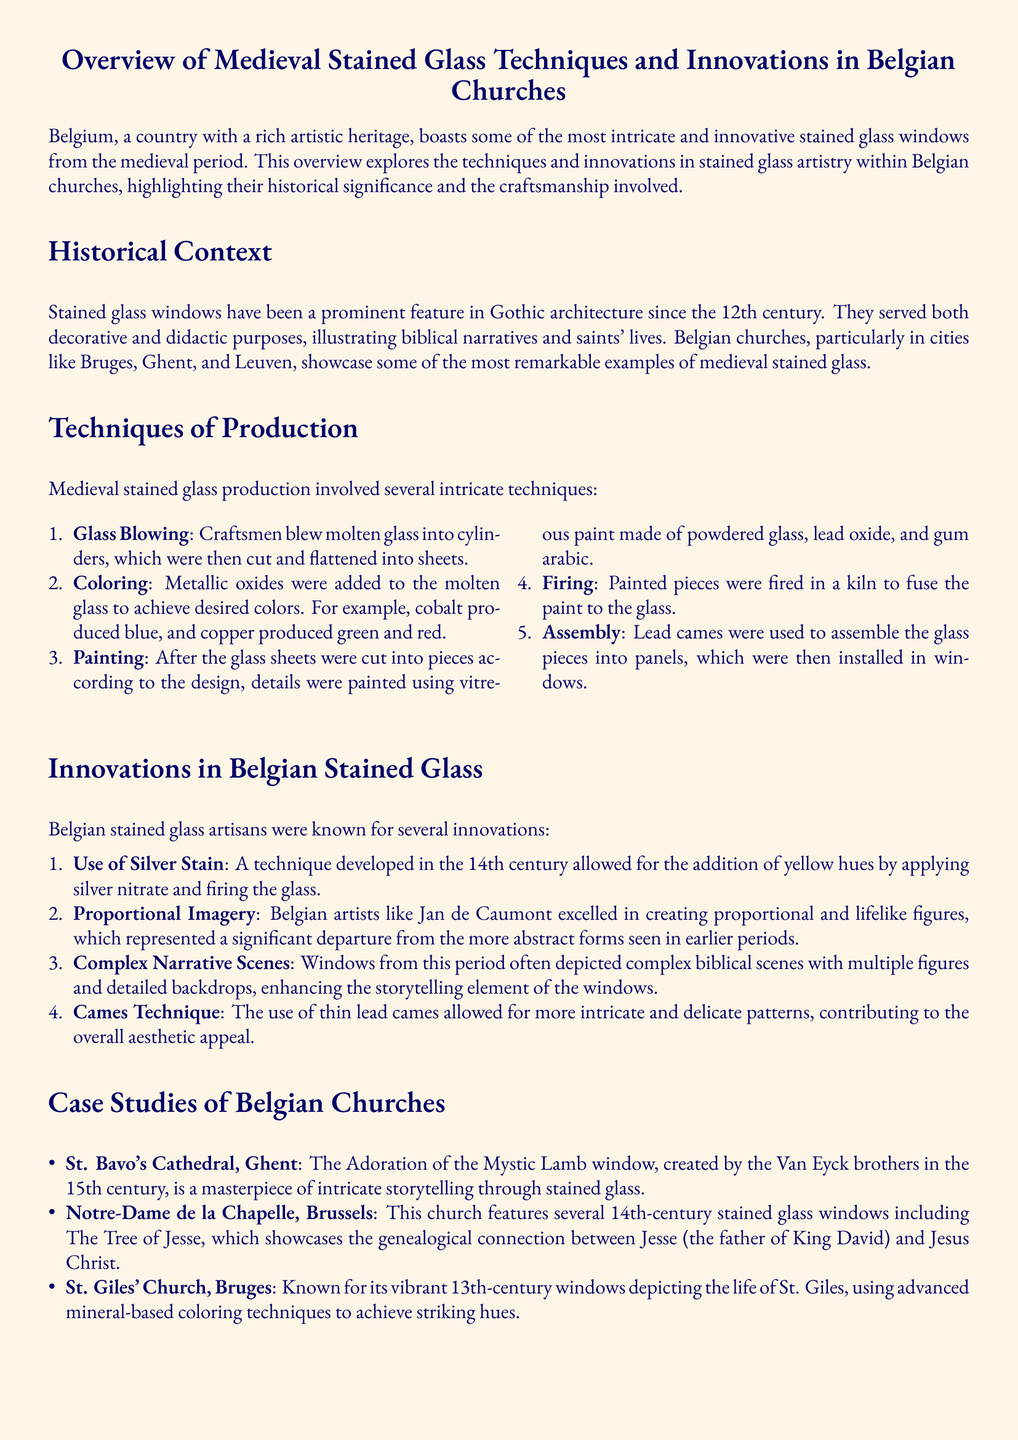What century did stained glass windows become prominent in Gothic architecture? The document states that stained glass windows have been a prominent feature in Gothic architecture since the 12th century.
Answer: 12th century Which artist is mentioned for excelling in proportional imagery? The document highlights Jan de Caumont as an artist who excelled in creating proportional and lifelike figures.
Answer: Jan de Caumont What process is used to fuse painted details onto the glass? According to the document, painted pieces were fused to the glass by firing them in a kiln.
Answer: Firing What technique allowed for the addition of yellow hues in stained glass? The document describes the use of silver stain as a technique developed for adding yellow hues.
Answer: Silver stain How many Belgian churches are specifically studied in the document? The document presents case studies specific to three Belgian churches and their stained glass.
Answer: Three What significant window created by the Van Eyck brothers is mentioned? The document refers to the Adoration of the Mystic Lamb window as a significant work by the Van Eyck brothers.
Answer: Adoration of the Mystic Lamb What coloring technique was advanced in the 13th-century windows of St. Giles' Church? The document notes that advanced mineral-based coloring techniques were used in St. Giles' Church windows.
Answer: Mineral-based coloring techniques What innovation allowed for more intricate stained glass patterns? The document explains that the use of thin lead cames contributed to the creation of more intricate patterns.
Answer: Cames Technique 